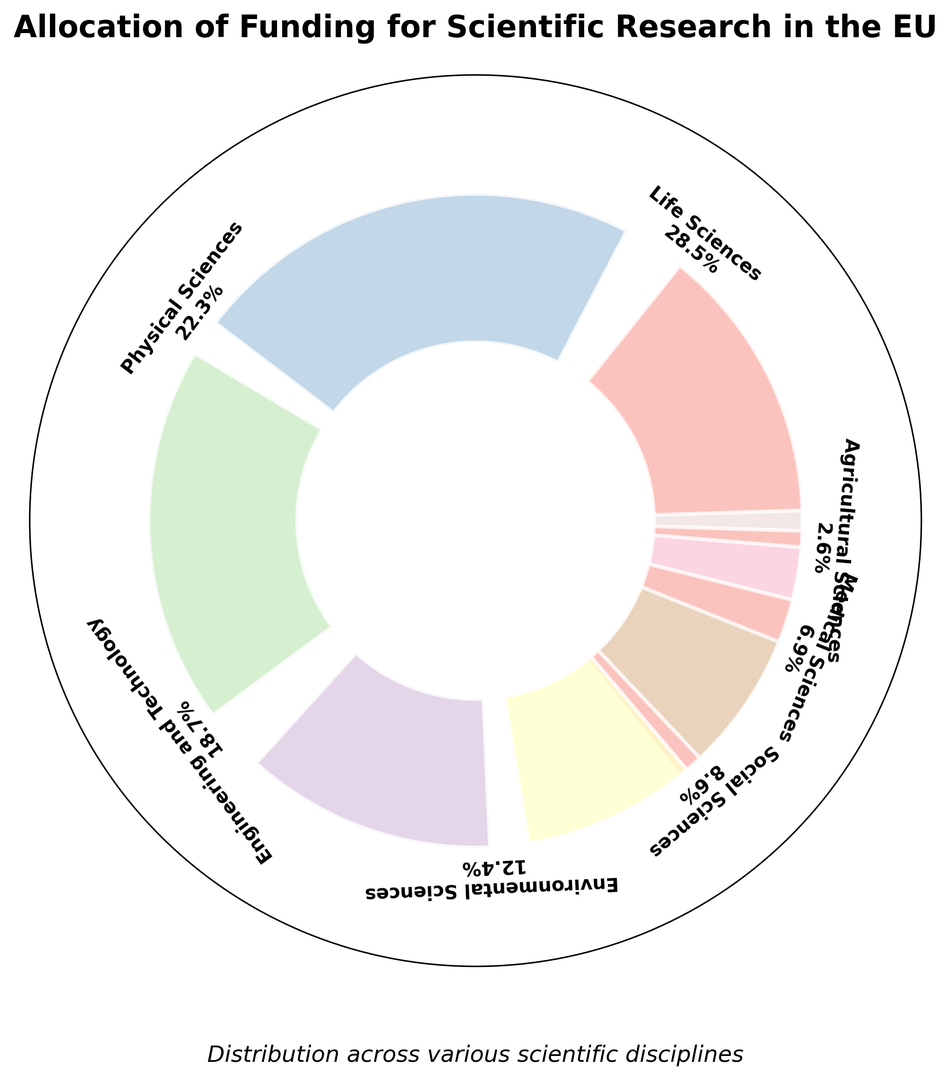What percentage of the total funding is allocated to Life Sciences and Medical Sciences combined? The percentages for Life Sciences and Medical Sciences are 28.5% and 6.9% respectively. Adding them together gives 28.5% + 6.9% = 35.4%.
Answer: 35.4% Which two categories have the highest funding allocations? The percentages are: Life Sciences 28.5%, Physical Sciences 22.3%, Engineering and Technology 18.7%, Environmental Sciences 12.4%, Social Sciences 8.6%, Medical Sciences 6.9%, Agricultural Sciences 2.6%, and Humanities 1.0%. The two highest are Life Sciences (28.5%) and Physical Sciences (22.3%).
Answer: Life Sciences and Physical Sciences What is the difference in funding between Physical Sciences and Environmental Sciences? The percentages for Physical Sciences and Environmental Sciences are 22.3% and 12.4% respectively. The difference is 22.3% - 12.4% = 9.9%.
Answer: 9.9% Is the percentage of funding for Social Sciences more or less than double that of Humanities? The percentage for Social Sciences is 8.6% and for Humanities it is 1.0%. Double of 1.0% is 2.0%. Since 8.6% is greater than 2.0%, Social Sciences funding is more than double that of Humanities.
Answer: More Which category has the smallest allocation of funding? The percentages for each category are given in the figure. The smallest percentage is for Humanities, which is 1.0%.
Answer: Humanities What is the combined percentage of funding allocated to Physical Sciences, Engineering and Technology, and Environmental Sciences? The percentages for Physical Sciences, Engineering and Technology, and Environmental Sciences are 22.3%, 18.7%, and 12.4%, respectively. Adding them together gives 22.3% + 18.7% + 12.4% = 53.4%.
Answer: 53.4% How does the Environmental Sciences funding compare to the Social Sciences funding? The percentage for Environmental Sciences is 12.4% and for Social Sciences it is 8.6%. Since 12.4% is greater than 8.6%, Environmental Sciences has more funding than Social Sciences.
Answer: Environmental Sciences has more What is the visual relationship between Life Sciences and Agricultural Sciences funding sections? The Life Sciences section is the largest and the Agricultural Sciences section is one of the smallest, indicating visually that Life Sciences has significantly more funding than Agricultural Sciences.
Answer: Life Sciences is significantly larger If the Medical Sciences funding were increased by 3%, what would its new percentage be, and how would that change the total funding percentage remaining? The current percentage for Medical Sciences is 6.9%. Increasing it by 3% gives 6.9% + 3% = 9.9%. The total percentage remains 100%, so the remaining funding would decrease by 3%.
Answer: 9.9% for Medical Sciences, and 97% remaining 